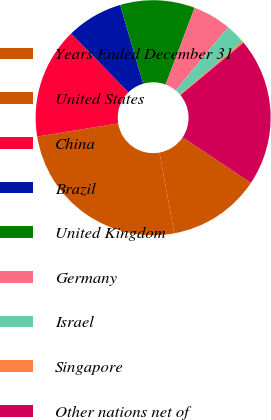Convert chart to OTSL. <chart><loc_0><loc_0><loc_500><loc_500><pie_chart><fcel>Years Ended December 31<fcel>United States<fcel>China<fcel>Brazil<fcel>United Kingdom<fcel>Germany<fcel>Israel<fcel>Singapore<fcel>Other nations net of<nl><fcel>12.77%<fcel>25.31%<fcel>15.28%<fcel>7.76%<fcel>10.27%<fcel>5.25%<fcel>2.74%<fcel>0.24%<fcel>20.38%<nl></chart> 